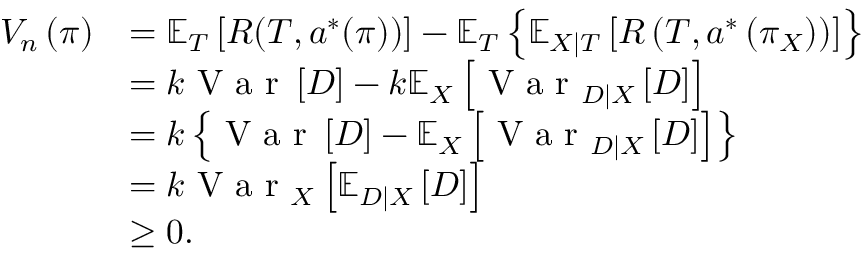<formula> <loc_0><loc_0><loc_500><loc_500>\begin{array} { r l } { V _ { n } \left ( \pi \right ) } & { = \mathbb { E } _ { T } \left [ R ( T , a ^ { * } ( \pi ) ) \right ] - \mathbb { E } _ { T } \left \{ \mathbb { E } _ { X | T } \left [ R \left ( T , a ^ { * } \left ( \pi _ { X } \right ) \right ) \right ] \right \} } \\ & { = k V a r \left [ D \right ] - k \mathbb { E } _ { X } \left [ { V a r _ { D | X } \left [ D \right ] } \right ] } \\ & { = k \left \{ { V a r \left [ D \right ] } - { \mathbb { E } _ { X } \left [ { V a r _ { D | X } \left [ D \right ] } \right ] } \right \} } \\ & { = k V a r _ { X } \left [ { \mathbb { E } _ { D | X } \left [ D \right ] } \right ] } \\ & { \geq 0 . } \end{array}</formula> 